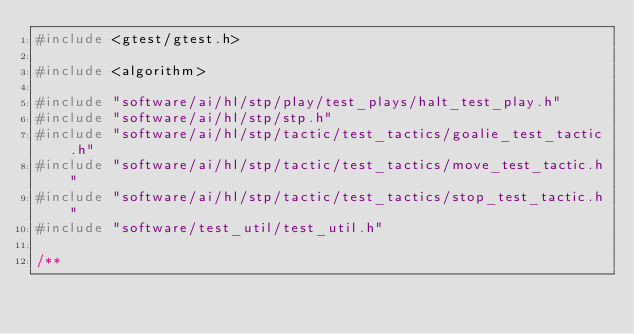Convert code to text. <code><loc_0><loc_0><loc_500><loc_500><_C++_>#include <gtest/gtest.h>

#include <algorithm>

#include "software/ai/hl/stp/play/test_plays/halt_test_play.h"
#include "software/ai/hl/stp/stp.h"
#include "software/ai/hl/stp/tactic/test_tactics/goalie_test_tactic.h"
#include "software/ai/hl/stp/tactic/test_tactics/move_test_tactic.h"
#include "software/ai/hl/stp/tactic/test_tactics/stop_test_tactic.h"
#include "software/test_util/test_util.h"

/**</code> 